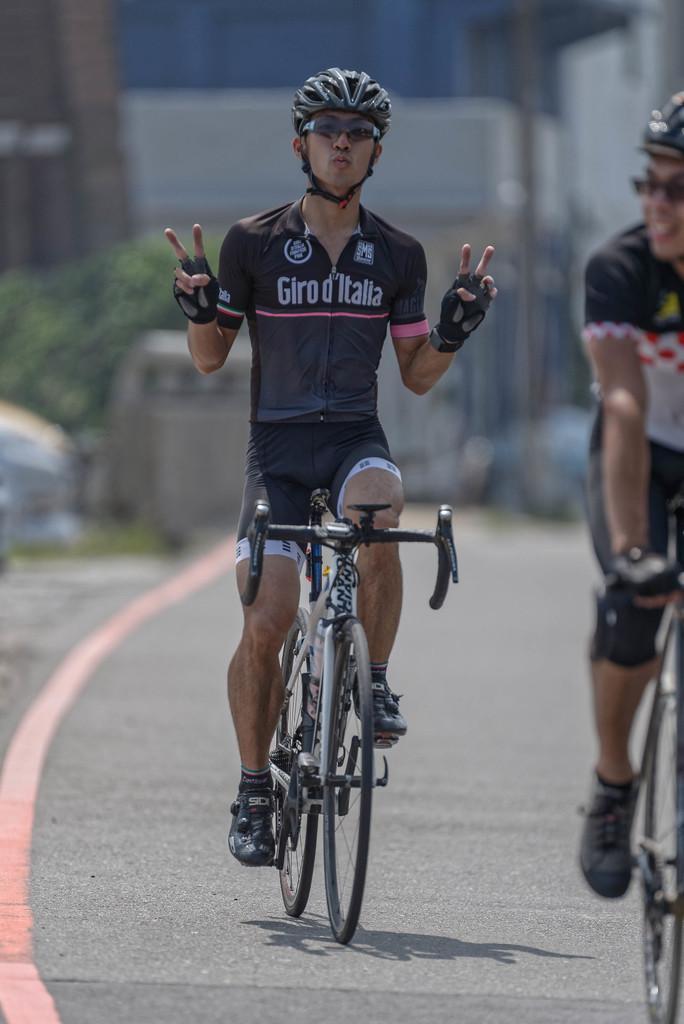Describe this image in one or two sentences. There is a person wearing helmet, goggles and gloves is sitting on a cycle. On the right side there is another person on a cycle. In the background it is blurred. 